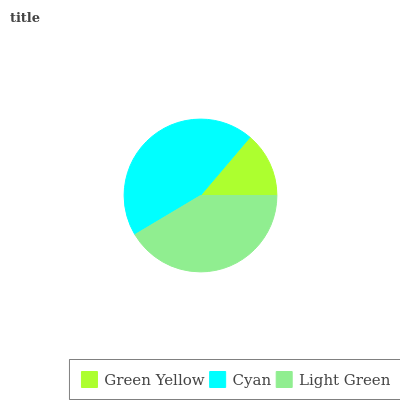Is Green Yellow the minimum?
Answer yes or no. Yes. Is Cyan the maximum?
Answer yes or no. Yes. Is Light Green the minimum?
Answer yes or no. No. Is Light Green the maximum?
Answer yes or no. No. Is Cyan greater than Light Green?
Answer yes or no. Yes. Is Light Green less than Cyan?
Answer yes or no. Yes. Is Light Green greater than Cyan?
Answer yes or no. No. Is Cyan less than Light Green?
Answer yes or no. No. Is Light Green the high median?
Answer yes or no. Yes. Is Light Green the low median?
Answer yes or no. Yes. Is Green Yellow the high median?
Answer yes or no. No. Is Green Yellow the low median?
Answer yes or no. No. 